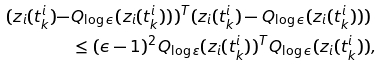<formula> <loc_0><loc_0><loc_500><loc_500>( z _ { i } ( t ^ { i } _ { k } ) - & Q _ { \log \epsilon } ( z _ { i } ( t ^ { i } _ { k } ) ) ) ^ { T } ( z _ { i } ( t ^ { i } _ { k } ) - Q _ { \log \epsilon } ( z _ { i } ( t ^ { i } _ { k } ) ) ) \\ & \leq ( \epsilon - 1 ) ^ { 2 } Q _ { \log \varepsilon } ( z _ { i } ( t ^ { i } _ { k } ) ) ^ { T } Q _ { \log \epsilon } ( z _ { i } ( t ^ { i } _ { k } ) ) ,</formula> 